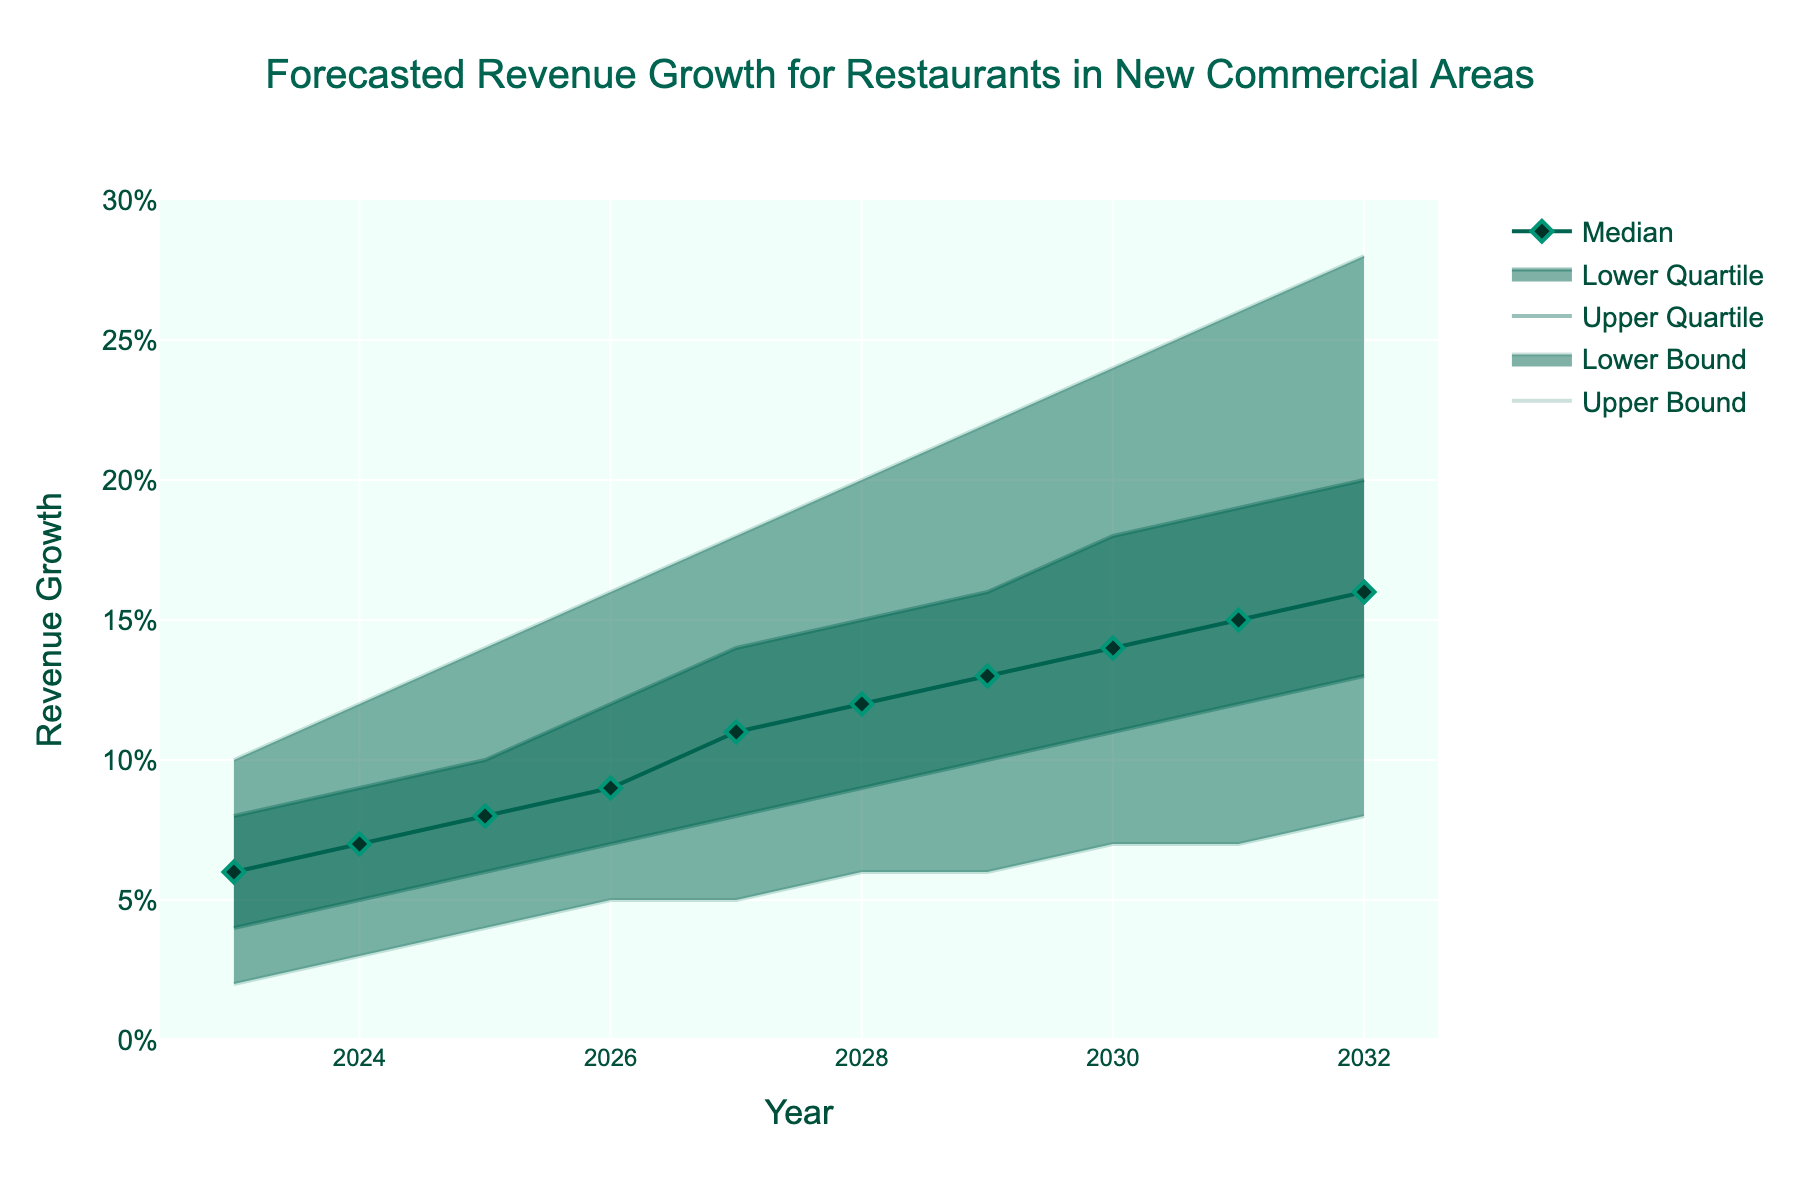What is the title of the figure? The title of the figure is the text that appears at the top and center. It provides an overview of what the chart is about.
Answer: Forecasted Revenue Growth for Restaurants in New Commercial Areas What is the revenue growth forecast for 2023 according to the median line? Look at the median line for the year 2023 and read the value. The median line is displayed with a line and diamond markers in the figure.
Answer: 6% In which year is the upper bound of revenue growth expected to exceed 20%? Identify the point where the upper bound line, which is the topmost line, crosses the 20% mark on the y-axis.
Answer: 2028 How do the lower quartile values change from 2023 to 2032? Observe the values of the lower quartile line at the beginning of the period (2023) and the end of the period (2032). Subtract the lower quartile value in 2023 from that in 2032.
Answer: Increase by 9% What’s the expected average median revenue growth from 2028 to 2032? Extract the median values for the years 2028 through 2032, sum them up, and then divide by the number of years (5).
Answer: (12%+13%+14%+15%+16%)/5 = 14% Which year shows the largest range between the lower bound and the upper bound? Calculate the range (difference) for each year by subtracting the lower bound from the upper bound and identify the year with the maximum range.
Answer: 2032 (28%-8% = 20%) Is there any period where the lower bound remains constant? Assess the lower bound line across all years and check if it stays the same for any consecutive years.
Answer: 2026-2027 and 2028-2029 Which year has the smallest difference between the median and the lower quartile? Calculate the difference between the median and lower quartile for each year and find the year with the smallest difference.
Answer: 2027 (11%-8% = 3%) Does the median revenue growth ever decrease? Observe the trend of the median line from 2023 to 2032 and check if there is any year where the value drops compared to the previous year.
Answer: No What is the trend in the upper quartile revenue growth from 2025 to 2029? Track the upper quartile values for the years 2025 to 2029 and determine if it is increasing, decreasing, or remaining stable.
Answer: Increasing 